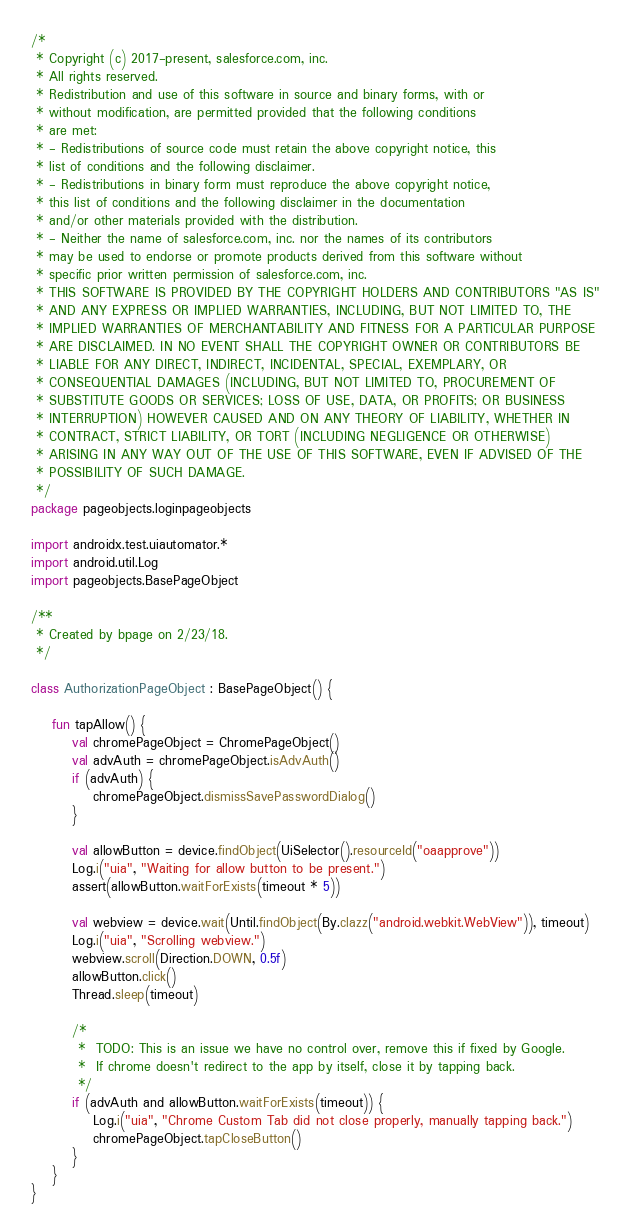Convert code to text. <code><loc_0><loc_0><loc_500><loc_500><_Kotlin_>/*
 * Copyright (c) 2017-present, salesforce.com, inc.
 * All rights reserved.
 * Redistribution and use of this software in source and binary forms, with or
 * without modification, are permitted provided that the following conditions
 * are met:
 * - Redistributions of source code must retain the above copyright notice, this
 * list of conditions and the following disclaimer.
 * - Redistributions in binary form must reproduce the above copyright notice,
 * this list of conditions and the following disclaimer in the documentation
 * and/or other materials provided with the distribution.
 * - Neither the name of salesforce.com, inc. nor the names of its contributors
 * may be used to endorse or promote products derived from this software without
 * specific prior written permission of salesforce.com, inc.
 * THIS SOFTWARE IS PROVIDED BY THE COPYRIGHT HOLDERS AND CONTRIBUTORS "AS IS"
 * AND ANY EXPRESS OR IMPLIED WARRANTIES, INCLUDING, BUT NOT LIMITED TO, THE
 * IMPLIED WARRANTIES OF MERCHANTABILITY AND FITNESS FOR A PARTICULAR PURPOSE
 * ARE DISCLAIMED. IN NO EVENT SHALL THE COPYRIGHT OWNER OR CONTRIBUTORS BE
 * LIABLE FOR ANY DIRECT, INDIRECT, INCIDENTAL, SPECIAL, EXEMPLARY, OR
 * CONSEQUENTIAL DAMAGES (INCLUDING, BUT NOT LIMITED TO, PROCUREMENT OF
 * SUBSTITUTE GOODS OR SERVICES; LOSS OF USE, DATA, OR PROFITS; OR BUSINESS
 * INTERRUPTION) HOWEVER CAUSED AND ON ANY THEORY OF LIABILITY, WHETHER IN
 * CONTRACT, STRICT LIABILITY, OR TORT (INCLUDING NEGLIGENCE OR OTHERWISE)
 * ARISING IN ANY WAY OUT OF THE USE OF THIS SOFTWARE, EVEN IF ADVISED OF THE
 * POSSIBILITY OF SUCH DAMAGE.
 */
package pageobjects.loginpageobjects

import androidx.test.uiautomator.*
import android.util.Log
import pageobjects.BasePageObject

/**
 * Created by bpage on 2/23/18.
 */

class AuthorizationPageObject : BasePageObject() {

    fun tapAllow() {
        val chromePageObject = ChromePageObject()
        val advAuth = chromePageObject.isAdvAuth()
        if (advAuth) {
            chromePageObject.dismissSavePasswordDialog()
        }

        val allowButton = device.findObject(UiSelector().resourceId("oaapprove"))
        Log.i("uia", "Waiting for allow button to be present.")
        assert(allowButton.waitForExists(timeout * 5))

        val webview = device.wait(Until.findObject(By.clazz("android.webkit.WebView")), timeout)
        Log.i("uia", "Scrolling webview.")
        webview.scroll(Direction.DOWN, 0.5f)
        allowButton.click()
        Thread.sleep(timeout)

        /*
         *  TODO: This is an issue we have no control over, remove this if fixed by Google.
         *  If chrome doesn't redirect to the app by itself, close it by tapping back.
         */
        if (advAuth and allowButton.waitForExists(timeout)) {
            Log.i("uia", "Chrome Custom Tab did not close properly, manually tapping back.")
            chromePageObject.tapCloseButton()
        }
    }
}</code> 